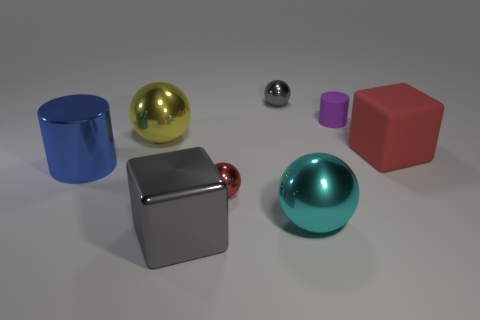Add 2 yellow matte blocks. How many objects exist? 10 Subtract all gray spheres. How many spheres are left? 3 Subtract all gray cubes. How many cubes are left? 1 Subtract 2 balls. How many balls are left? 2 Subtract all gray balls. How many gray cylinders are left? 0 Subtract all small red metallic balls. Subtract all large cyan metallic balls. How many objects are left? 6 Add 1 blocks. How many blocks are left? 3 Add 7 green balls. How many green balls exist? 7 Subtract 1 blue cylinders. How many objects are left? 7 Subtract all blocks. How many objects are left? 6 